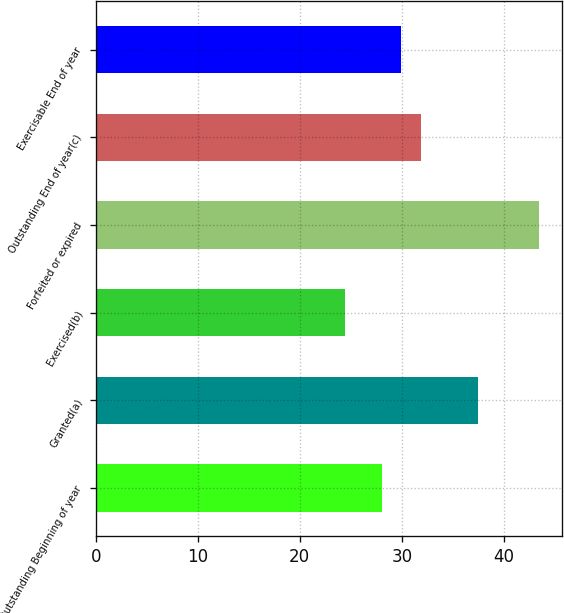<chart> <loc_0><loc_0><loc_500><loc_500><bar_chart><fcel>Outstanding Beginning of year<fcel>Granted(a)<fcel>Exercised(b)<fcel>Forfeited or expired<fcel>Outstanding End of year(c)<fcel>Exercisable End of year<nl><fcel>28.06<fcel>37.42<fcel>24.47<fcel>43.47<fcel>31.86<fcel>29.96<nl></chart> 